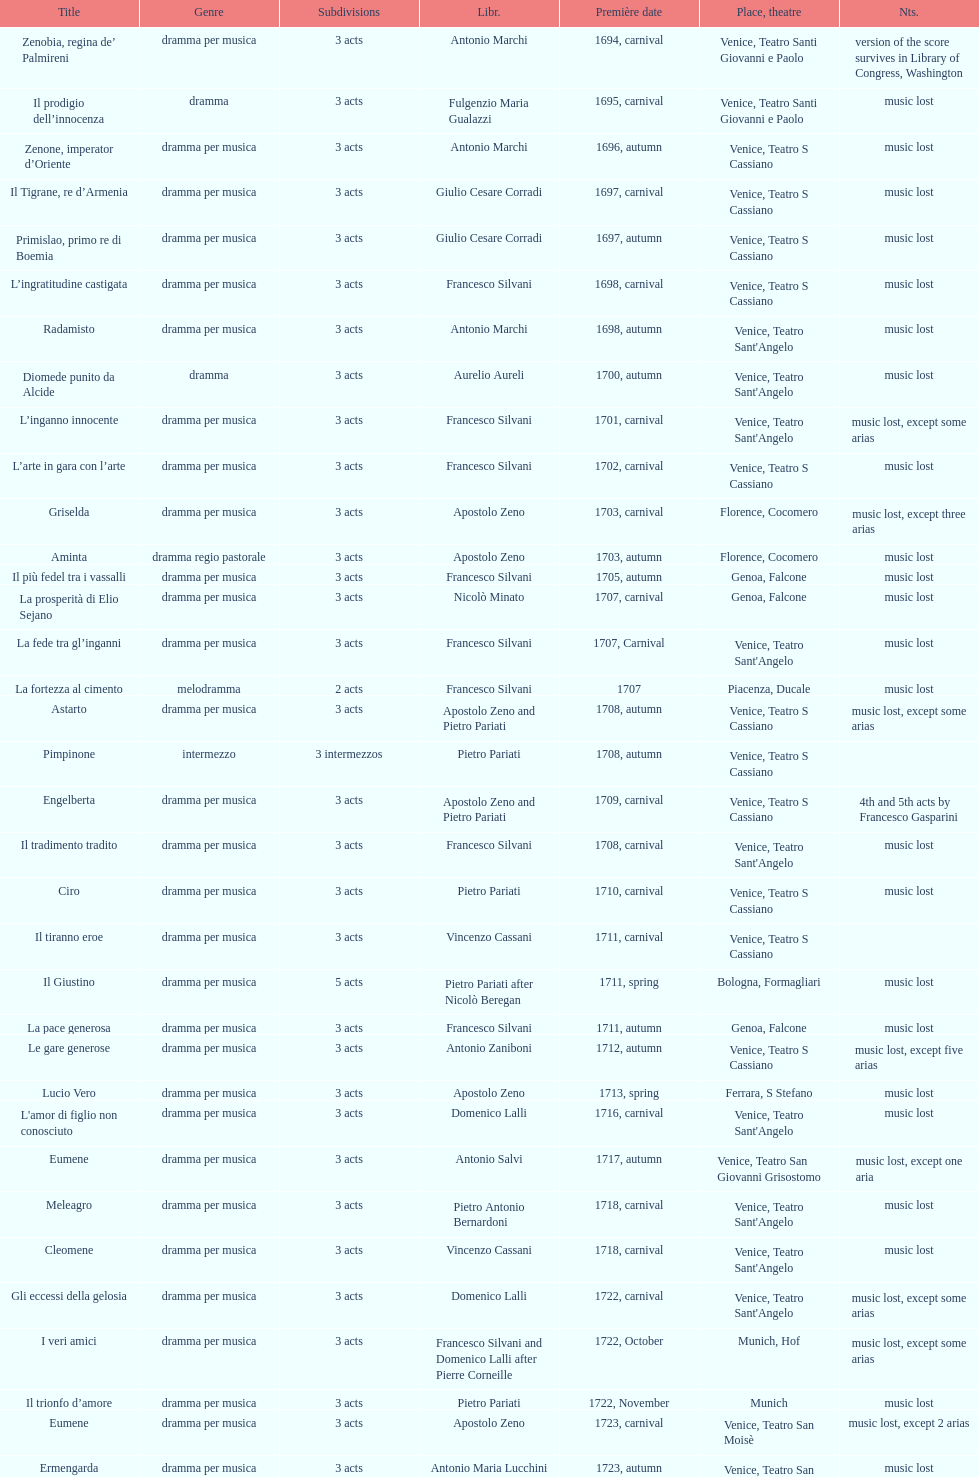What number of acts does il giustino have? 5. 